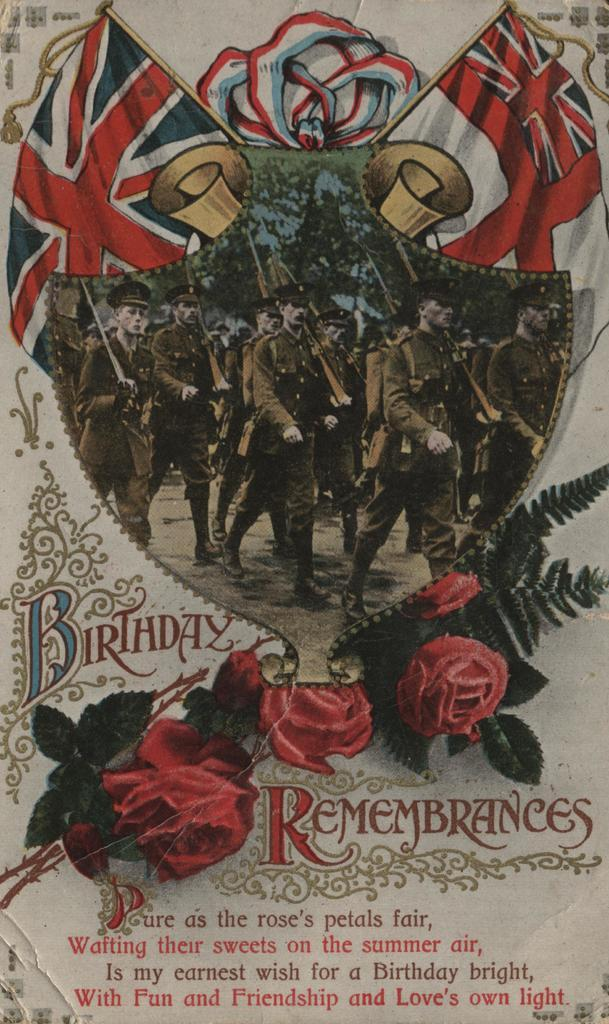<image>
Create a compact narrative representing the image presented. a group of soldiers march with the word birthday under them 